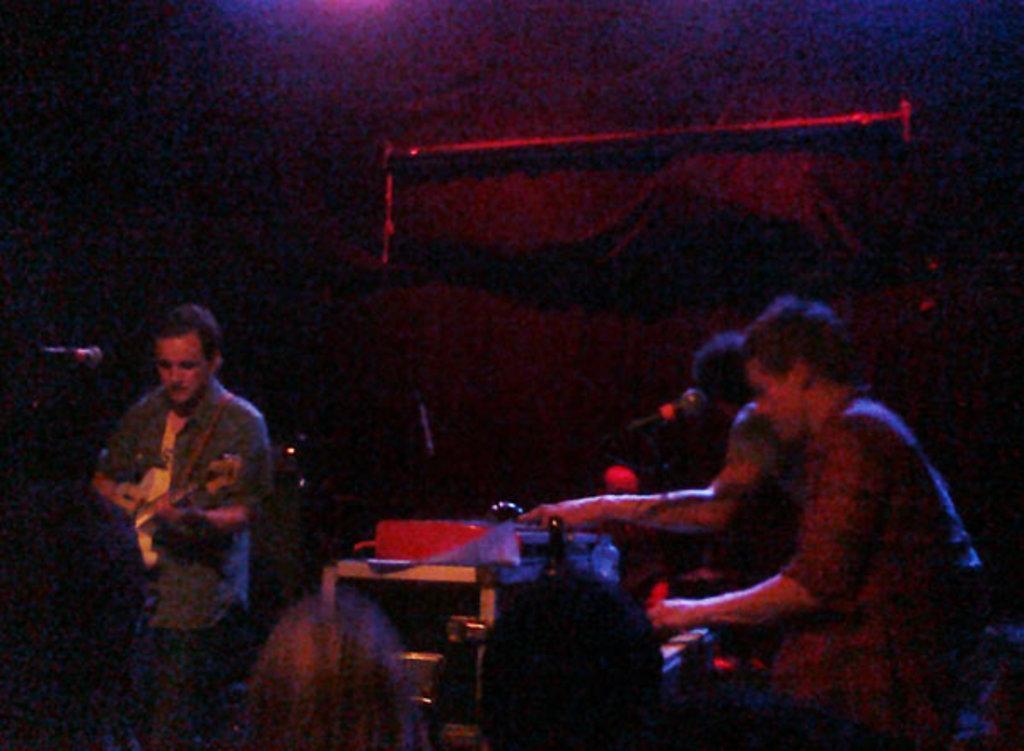How would you summarize this image in a sentence or two? These people are playing musical instruments. In-front of them there are mics. Background it is dark. 